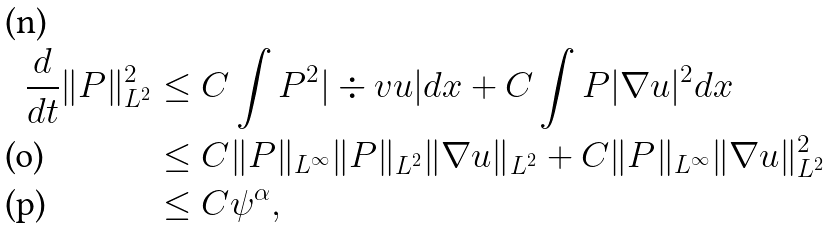<formula> <loc_0><loc_0><loc_500><loc_500>\frac { d } { d t } \| P \| _ { L ^ { 2 } } ^ { 2 } & \leq C \int P ^ { 2 } | \div v u | d x + C \int P | \nabla u | ^ { 2 } d x \\ & \leq C \| P \| _ { L ^ { \infty } } \| P \| _ { L ^ { 2 } } \| \nabla u \| _ { L ^ { 2 } } + C \| P \| _ { L ^ { \infty } } \| \nabla u \| _ { L ^ { 2 } } ^ { 2 } \\ & \leq C \psi ^ { \alpha } ,</formula> 